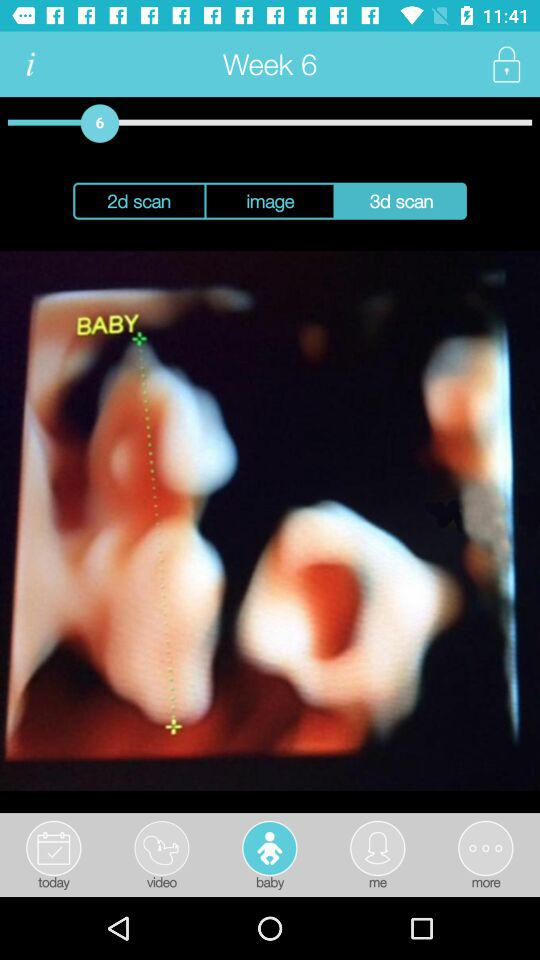Which button has been selected in the bottom row? The selected button is "baby". 